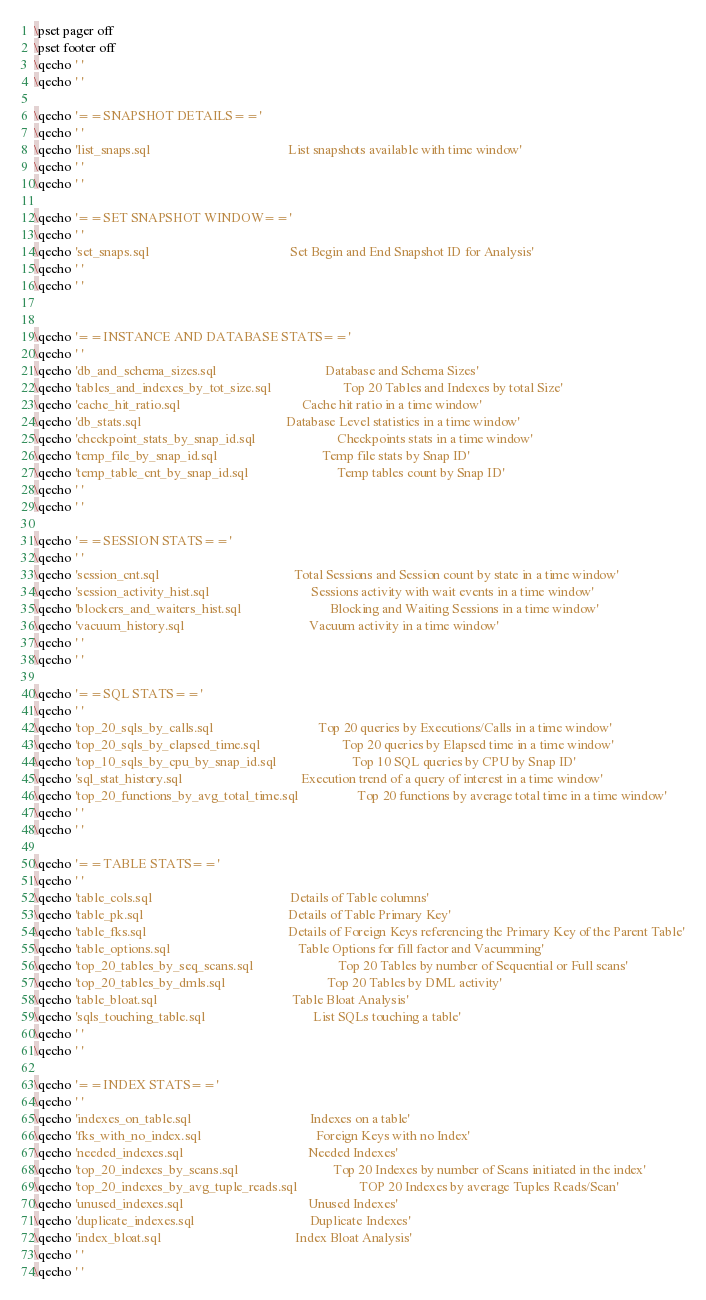Convert code to text. <code><loc_0><loc_0><loc_500><loc_500><_SQL_>\pset pager off
\pset footer off
\qecho ' '
\qecho ' '

\qecho '==SNAPSHOT DETAILS=='
\qecho ' '
\qecho 'list_snaps.sql                                          List snapshots available with time window'
\qecho ' '
\qecho ' '

\qecho '==SET SNAPSHOT WINDOW=='
\qecho ' '
\qecho 'set_snaps.sql                                           Set Begin and End Snapshot ID for Analysis'
\qecho ' '
\qecho ' '


\qecho '==INSTANCE AND DATABASE STATS=='
\qecho ' '
\qecho 'db_and_schema_sizes.sql                                 Database and Schema Sizes'
\qecho 'tables_and_indexes_by_tot_size.sql                      Top 20 Tables and Indexes by total Size'
\qecho 'cache_hit_ratio.sql                                     Cache hit ratio in a time window'
\qecho 'db_stats.sql                                            Database Level statistics in a time window'
\qecho 'checkpoint_stats_by_snap_id.sql                         Checkpoints stats in a time window'
\qecho 'temp_file_by_snap_id.sql                                Temp file stats by Snap ID'
\qecho 'temp_table_cnt_by_snap_id.sql                           Temp tables count by Snap ID'
\qecho ' '
\qecho ' '

\qecho '==SESSION STATS=='
\qecho ' '
\qecho 'session_cnt.sql                                         Total Sessions and Session count by state in a time window'
\qecho 'session_activity_hist.sql                               Sessions activity with wait events in a time window'
\qecho 'blockers_and_waiters_hist.sql                           Blocking and Waiting Sessions in a time window'
\qecho 'vacuum_history.sql                                      Vacuum activity in a time window'
\qecho ' '
\qecho ' '

\qecho '==SQL STATS=='
\qecho ' '
\qecho 'top_20_sqls_by_calls.sql                                Top 20 queries by Executions/Calls in a time window'
\qecho 'top_20_sqls_by_elapsed_time.sql                         Top 20 queries by Elapsed time in a time window'
\qecho 'top_10_sqls_by_cpu_by_snap_id.sql                       Top 10 SQL queries by CPU by Snap ID'
\qecho 'sql_stat_history.sql                                    Execution trend of a query of interest in a time window'
\qecho 'top_20_functions_by_avg_total_time.sql                  Top 20 functions by average total time in a time window'
\qecho ' '
\qecho ' '

\qecho '==TABLE STATS=='
\qecho ' '
\qecho 'table_cols.sql                                          Details of Table columns'
\qecho 'table_pk.sql                                            Details of Table Primary Key'
\qecho 'table_fks.sql                                           Details of Foreign Keys referencing the Primary Key of the Parent Table'
\qecho 'table_options.sql                                       Table Options for fill factor and Vacumming'
\qecho 'top_20_tables_by_seq_scans.sql                          Top 20 Tables by number of Sequential or Full scans'
\qecho 'top_20_tables_by_dmls.sql                               Top 20 Tables by DML activity'
\qecho 'table_bloat.sql                                         Table Bloat Analysis'
\qecho 'sqls_touching_table.sql                                 List SQLs touching a table'
\qecho ' '
\qecho ' '

\qecho '==INDEX STATS=='
\qecho ' '
\qecho 'indexes_on_table.sql                                    Indexes on a table'
\qecho 'fks_with_no_index.sql                                   Foreign Keys with no Index'
\qecho 'needed_indexes.sql                                      Needed Indexes'
\qecho 'top_20_indexes_by_scans.sql                             Top 20 Indexes by number of Scans initiated in the index'
\qecho 'top_20_indexes_by_avg_tuple_reads.sql                   TOP 20 Indexes by average Tuples Reads/Scan'
\qecho 'unused_indexes.sql                                      Unused Indexes'
\qecho 'duplicate_indexes.sql                                   Duplicate Indexes'
\qecho 'index_bloat.sql                                         Index Bloat Analysis'
\qecho ' '
\qecho ' '</code> 